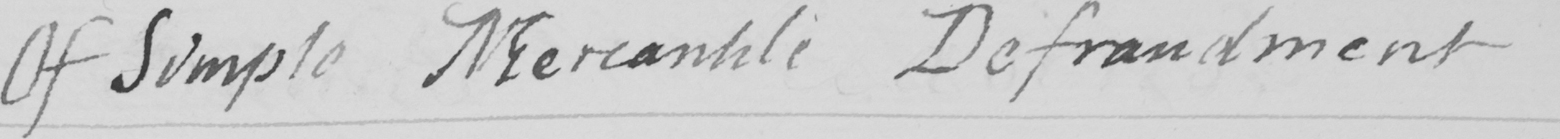Transcribe the text shown in this historical manuscript line. Of Simple Mercantile Defraudment 